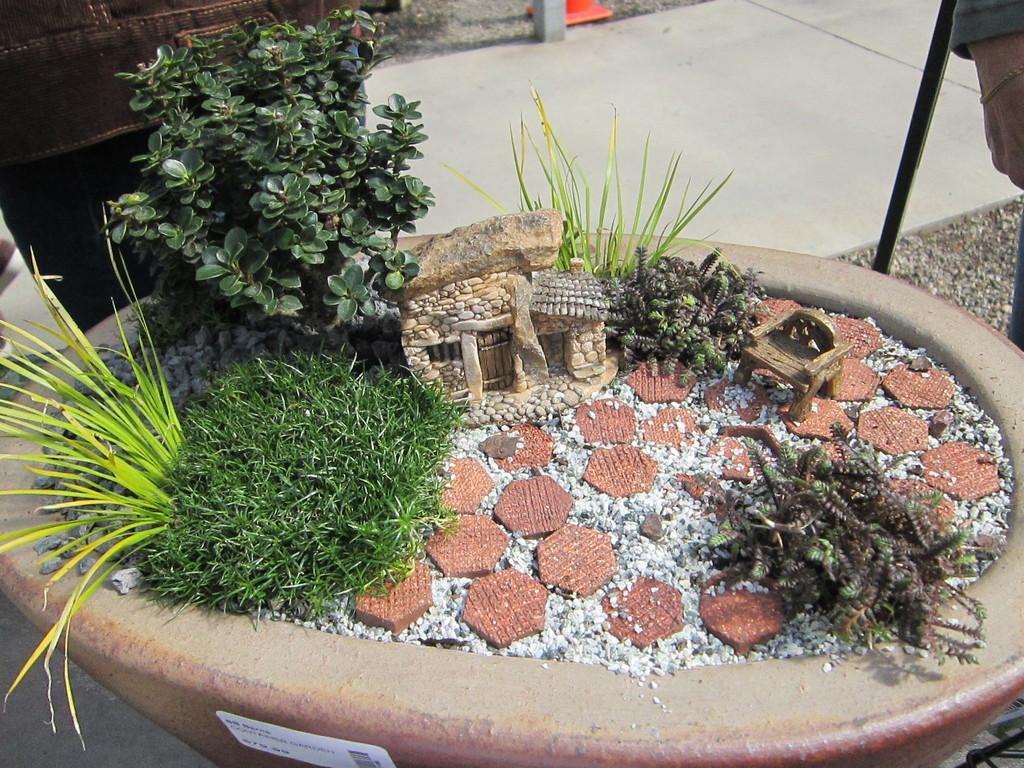How would you summarize this image in a sentence or two? In this picture I can observe scale model of a stone house in the middle of the picture. I can observe plants on the left side. In the background I can observe floor. 